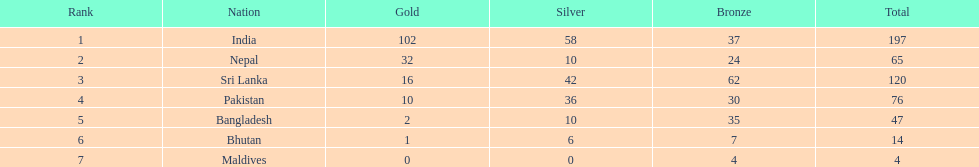How many gold medals has india secured? 102. 